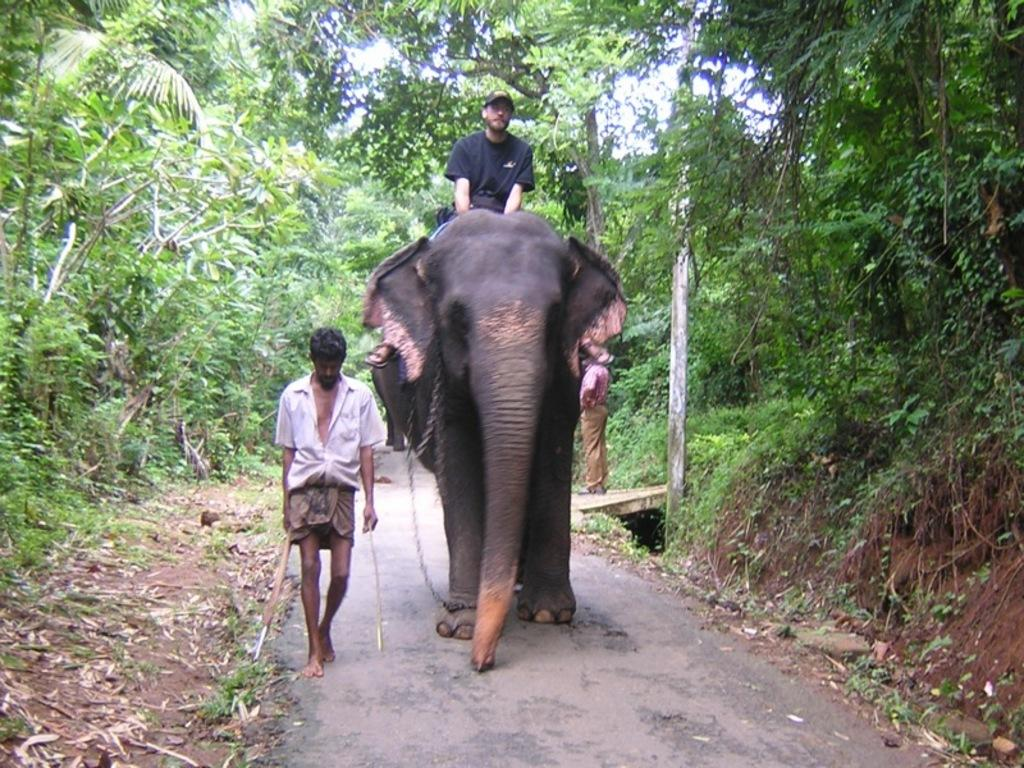What is the person in the image wearing? The person in the image is wearing a black shirt. What is the person doing in the image? The person is sitting on an elephant. Who else is present in the image? There is another person standing in front of the elephant. What can be seen in the background of the image? There are trees visible in the background of the image. How does the person sitting on the elephant make a quiet offer to the standing person? There is no indication in the image that the person sitting on the elephant is making an offer, quiet or otherwise, to the standing person. 